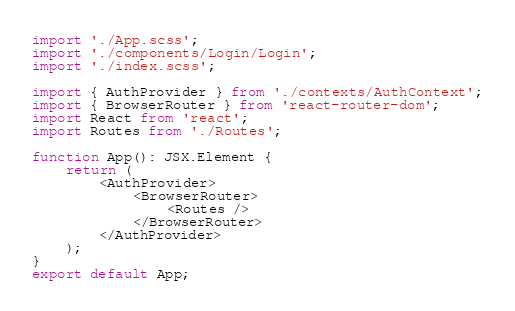Convert code to text. <code><loc_0><loc_0><loc_500><loc_500><_TypeScript_>import './App.scss';
import './components/Login/Login';
import './index.scss';

import { AuthProvider } from './contexts/AuthContext';
import { BrowserRouter } from 'react-router-dom';
import React from 'react';
import Routes from './Routes';

function App(): JSX.Element {
	return (
		<AuthProvider>
			<BrowserRouter>
				<Routes />
			</BrowserRouter>
		</AuthProvider>
	);
}
export default App;
</code> 